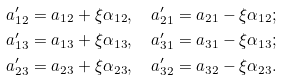<formula> <loc_0><loc_0><loc_500><loc_500>a ^ { \prime } _ { 1 2 } & = a _ { 1 2 } + \xi \alpha _ { 1 2 } , \quad a ^ { \prime } _ { 2 1 } = a _ { 2 1 } - \xi \alpha _ { 1 2 } ; \\ a ^ { \prime } _ { 1 3 } & = a _ { 1 3 } + \xi \alpha _ { 1 3 } , \quad a ^ { \prime } _ { 3 1 } = a _ { 3 1 } - \xi \alpha _ { 1 3 } ; \\ a ^ { \prime } _ { 2 3 } & = a _ { 2 3 } + \xi \alpha _ { 2 3 } , \quad a ^ { \prime } _ { 3 2 } = a _ { 3 2 } - \xi \alpha _ { 2 3 } .</formula> 